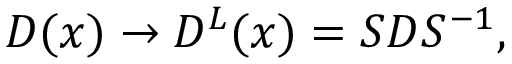<formula> <loc_0><loc_0><loc_500><loc_500>D ( x ) \rightarrow D ^ { L } ( x ) = S D S ^ { - 1 } ,</formula> 